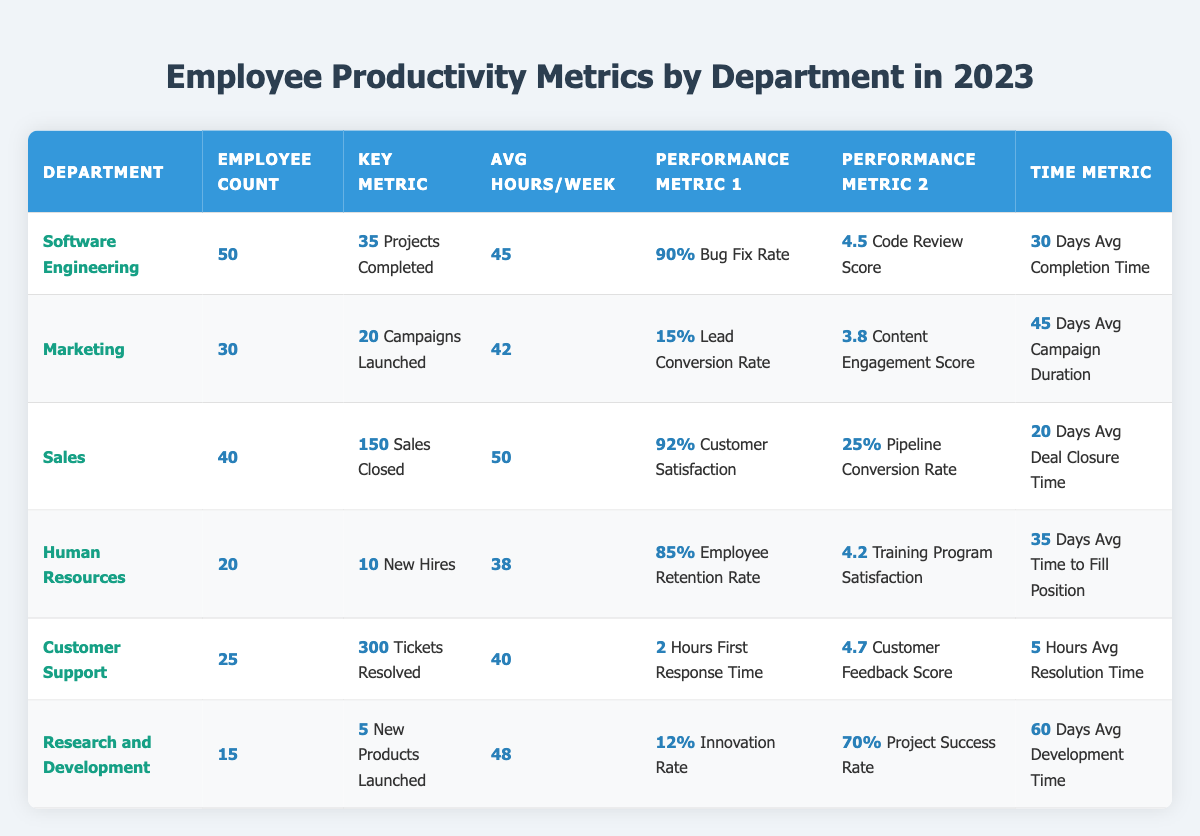What is the employee count in the Sales department? The table lists the "Sales" department in one of its rows, where it indicates the employee count as 40.
Answer: 40 Which department has the highest customer satisfaction percentage? Looking at the "Sales" department, it has a customer satisfaction percentage marked as 92%, which is higher than the percentages from other departments.
Answer: Sales How many new products were launched by the Research and Development department? The "Research and Development" row shows that 5 new products were launched, which answers the question directly.
Answer: 5 What is the average time (in days) taken to fill a position in the Human Resources department? The "Human Resources" department shows an average time to fill a position stated as 35 days in the respective column.
Answer: 35 days Which department has the highest number of tickets resolved and what is that number? The highest tickets resolved are shown in the "Customer Support" department, with a total of 300 tickets resolved indicated in the table.
Answer: 300 tickets What is the average completion time for projects in the Software Engineering department in days? From the table, the average completion time under "Software Engineering" is clearly stated as 30 days.
Answer: 30 days What percentage of leads were converted in the Marketing department? The "Marketing" department has a lead conversion rate percentage of 15% listed in its corresponding column.
Answer: 15% Calculate the total number of projects completed in both the Software Engineering and Research and Development departments. Summing the projects completed: Software Engineering has 35 projects and Research and Development has 5 projects, so the total is 35 + 5 = 40 projects completed.
Answer: 40 projects Is the average hours worked per week higher in the Sales department compared to the Marketing department? The average hours per week for Sales is 50, while for Marketing it is 42. Since 50 is greater than 42, the statement is true.
Answer: Yes What is the difference in average hours per week between the Customer Support and Human Resources departments? For Customer Support, it’s 40 hours and for Human Resources, it’s 38 hours. Therefore, the difference is 40 - 38 = 2 hours.
Answer: 2 hours 